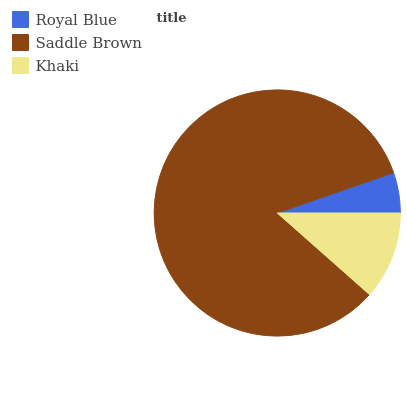Is Royal Blue the minimum?
Answer yes or no. Yes. Is Saddle Brown the maximum?
Answer yes or no. Yes. Is Khaki the minimum?
Answer yes or no. No. Is Khaki the maximum?
Answer yes or no. No. Is Saddle Brown greater than Khaki?
Answer yes or no. Yes. Is Khaki less than Saddle Brown?
Answer yes or no. Yes. Is Khaki greater than Saddle Brown?
Answer yes or no. No. Is Saddle Brown less than Khaki?
Answer yes or no. No. Is Khaki the high median?
Answer yes or no. Yes. Is Khaki the low median?
Answer yes or no. Yes. Is Royal Blue the high median?
Answer yes or no. No. Is Royal Blue the low median?
Answer yes or no. No. 